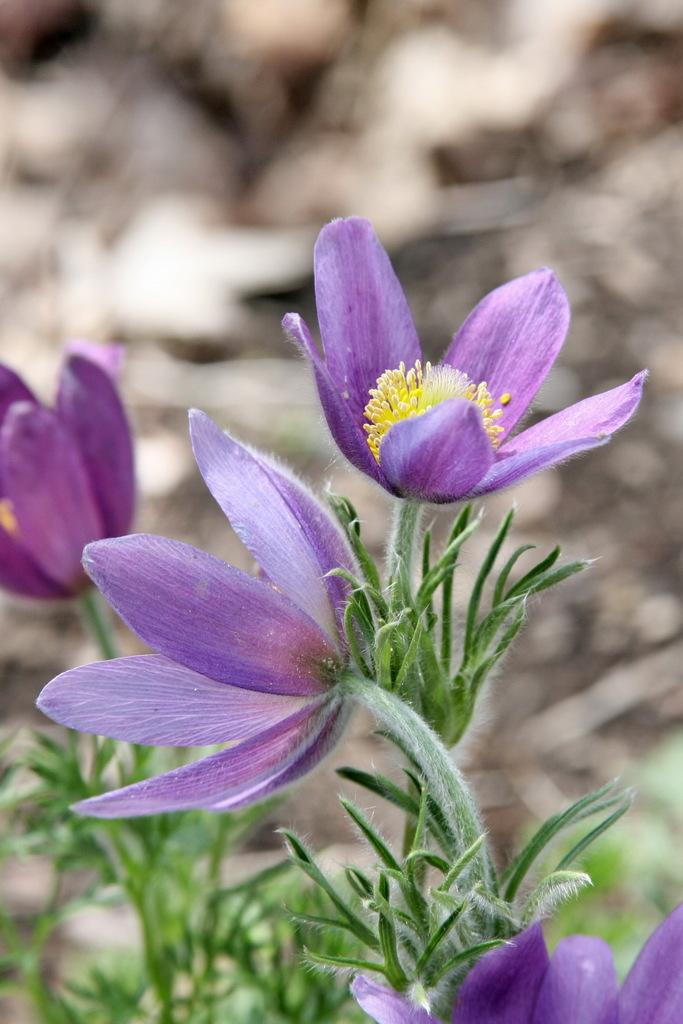What color are the flowers in the image? The flowers in the image are violet. Where are the flowers located? The flowers are on plants. Can you describe the background of the image? The background of the image is blurred. What type of instrument is being played in the background of the image? There is no instrument being played in the background of the image, as the provided facts do not mention any musical instruments. 